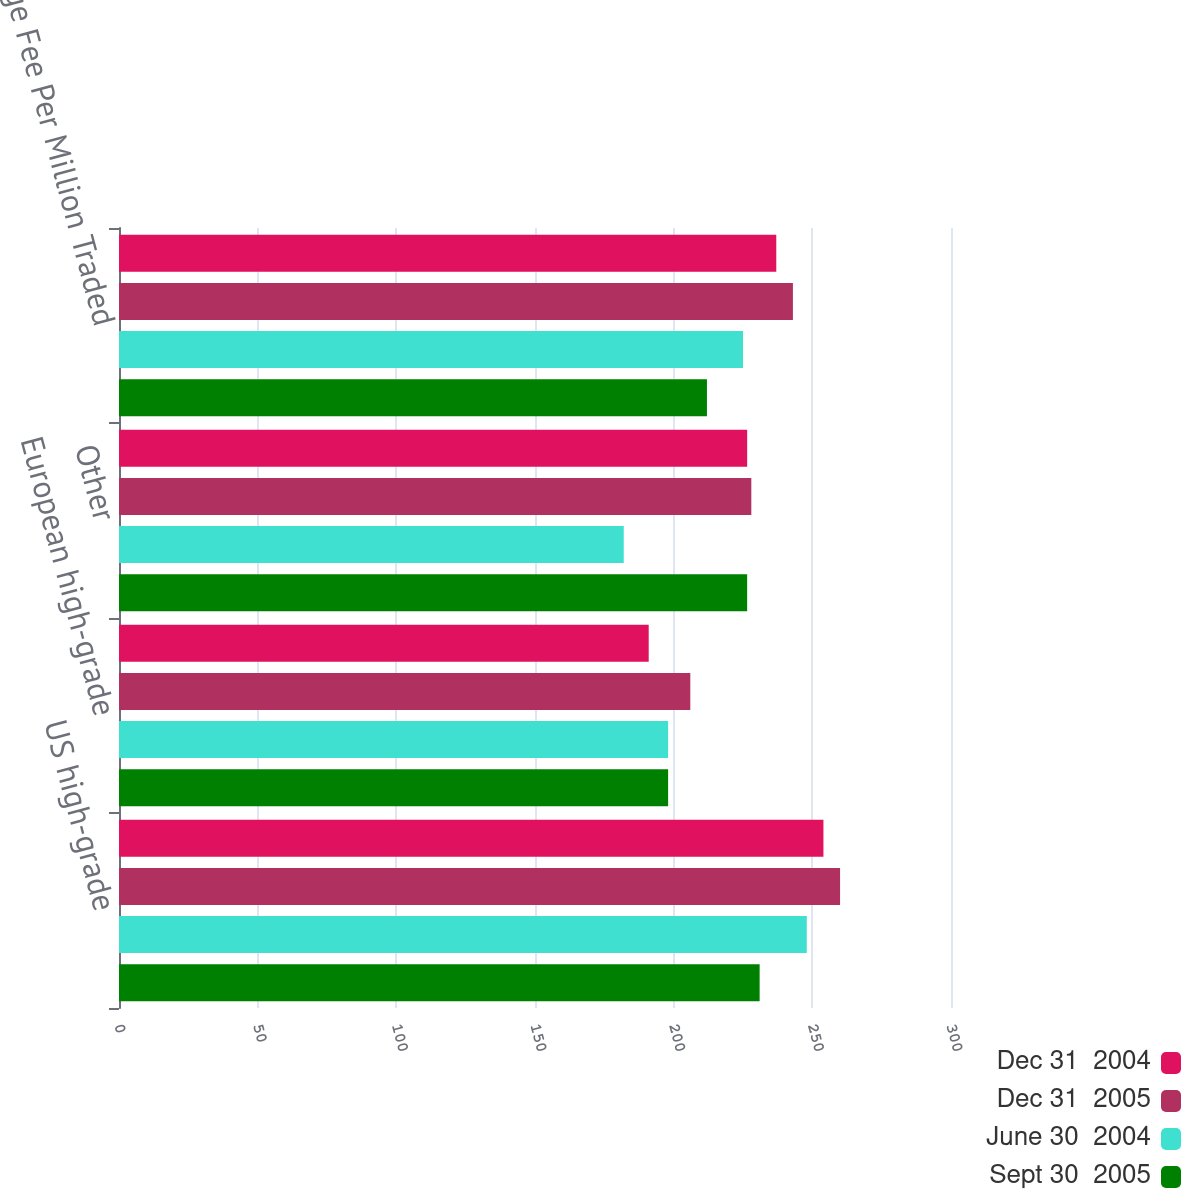Convert chart. <chart><loc_0><loc_0><loc_500><loc_500><stacked_bar_chart><ecel><fcel>US high-grade<fcel>European high-grade<fcel>Other<fcel>Average Fee Per Million Traded<nl><fcel>Dec 31  2004<fcel>254<fcel>191<fcel>226.5<fcel>237<nl><fcel>Dec 31  2005<fcel>260<fcel>206<fcel>228<fcel>243<nl><fcel>June 30  2004<fcel>248<fcel>198<fcel>182<fcel>225<nl><fcel>Sept 30  2005<fcel>231<fcel>198<fcel>226.5<fcel>212<nl></chart> 